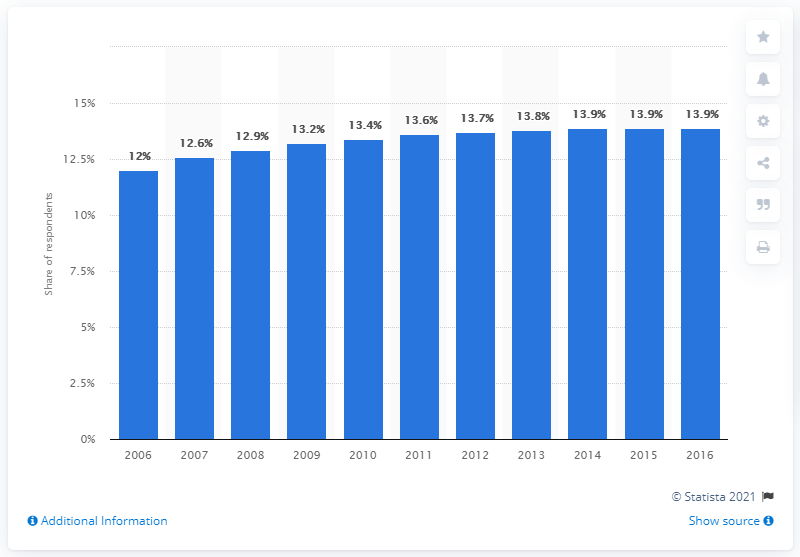Specify some key components in this picture. The last time that people in the UK had high blood pressure was in 2006. 